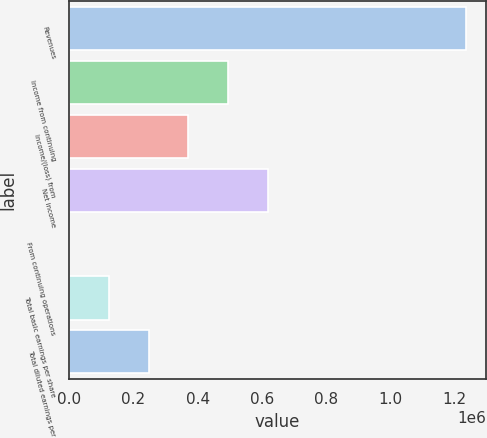Convert chart to OTSL. <chart><loc_0><loc_0><loc_500><loc_500><bar_chart><fcel>Revenues<fcel>Income from continuing<fcel>Income/(loss) from<fcel>Net income<fcel>From continuing operations<fcel>Total basic earnings per share<fcel>Total diluted earnings per<nl><fcel>1.2374e+06<fcel>494961<fcel>371221<fcel>618701<fcel>0.81<fcel>123741<fcel>247481<nl></chart> 